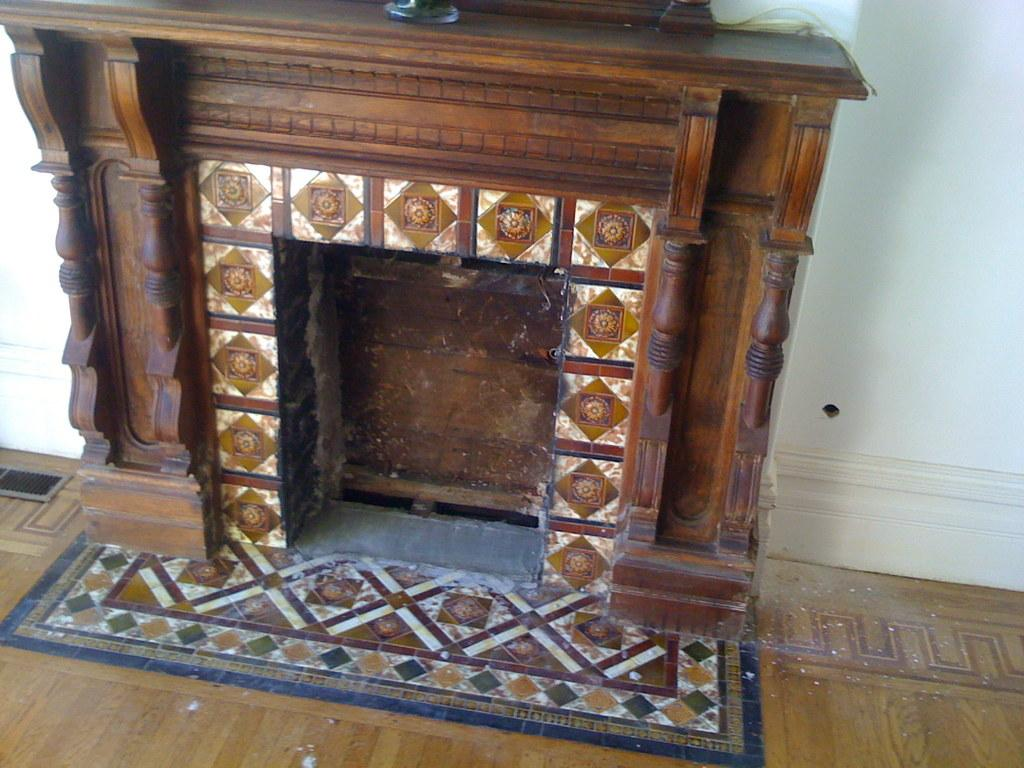What type of fireplace is visible in the image? There is a wooden fireplace in the image. What can be seen in the background of the image? There is a wall in the background of the image. What color is the blood dripping from the wall in the image? There is no blood or any indication of blood in the image; it only features a wooden fireplace and a wall. 